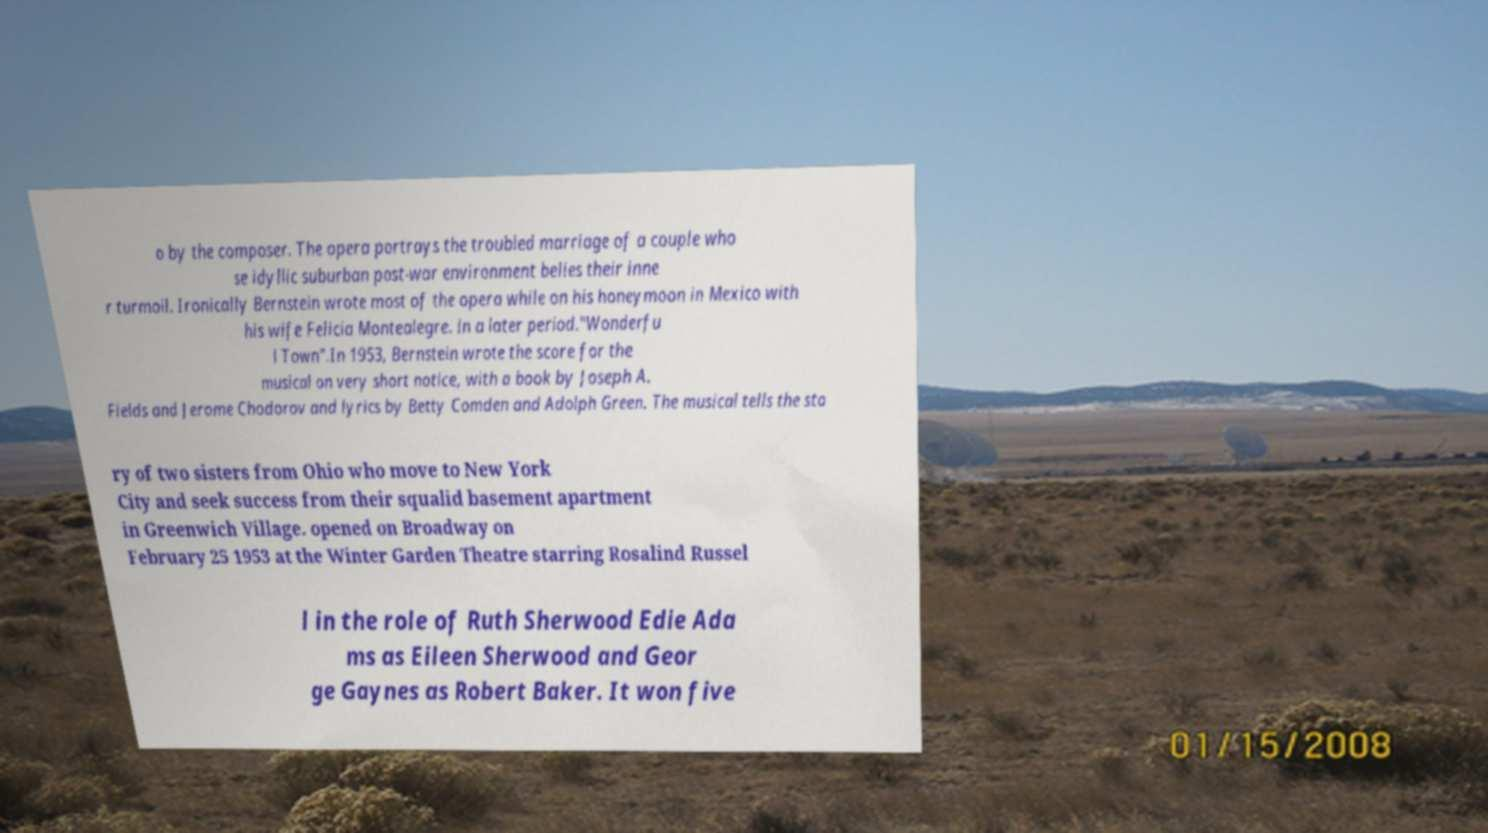There's text embedded in this image that I need extracted. Can you transcribe it verbatim? o by the composer. The opera portrays the troubled marriage of a couple who se idyllic suburban post-war environment belies their inne r turmoil. Ironically Bernstein wrote most of the opera while on his honeymoon in Mexico with his wife Felicia Montealegre. in a later period."Wonderfu l Town".In 1953, Bernstein wrote the score for the musical on very short notice, with a book by Joseph A. Fields and Jerome Chodorov and lyrics by Betty Comden and Adolph Green. The musical tells the sto ry of two sisters from Ohio who move to New York City and seek success from their squalid basement apartment in Greenwich Village. opened on Broadway on February 25 1953 at the Winter Garden Theatre starring Rosalind Russel l in the role of Ruth Sherwood Edie Ada ms as Eileen Sherwood and Geor ge Gaynes as Robert Baker. It won five 